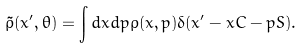Convert formula to latex. <formula><loc_0><loc_0><loc_500><loc_500>\tilde { \rho } ( x ^ { \prime } , \theta ) = \int d x d p \rho ( x , p ) \delta ( x ^ { \prime } - x C - p S ) .</formula> 